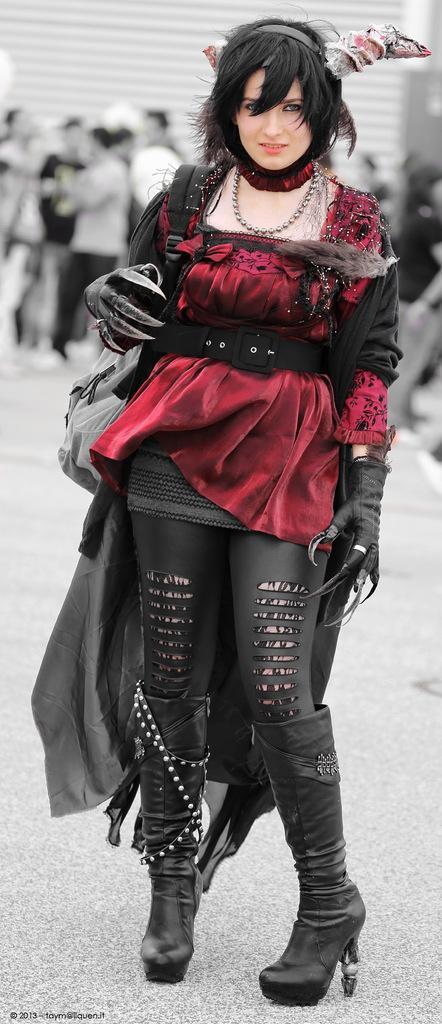Please provide a concise description of this image. In this image I can see woman is standing. She is wearing maroon and black color dress. We can see black boots,headwear and chain. Back Side I can see few people. 